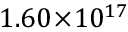<formula> <loc_0><loc_0><loc_500><loc_500>1 . 6 0 \, \times \, 1 0 ^ { 1 7 }</formula> 